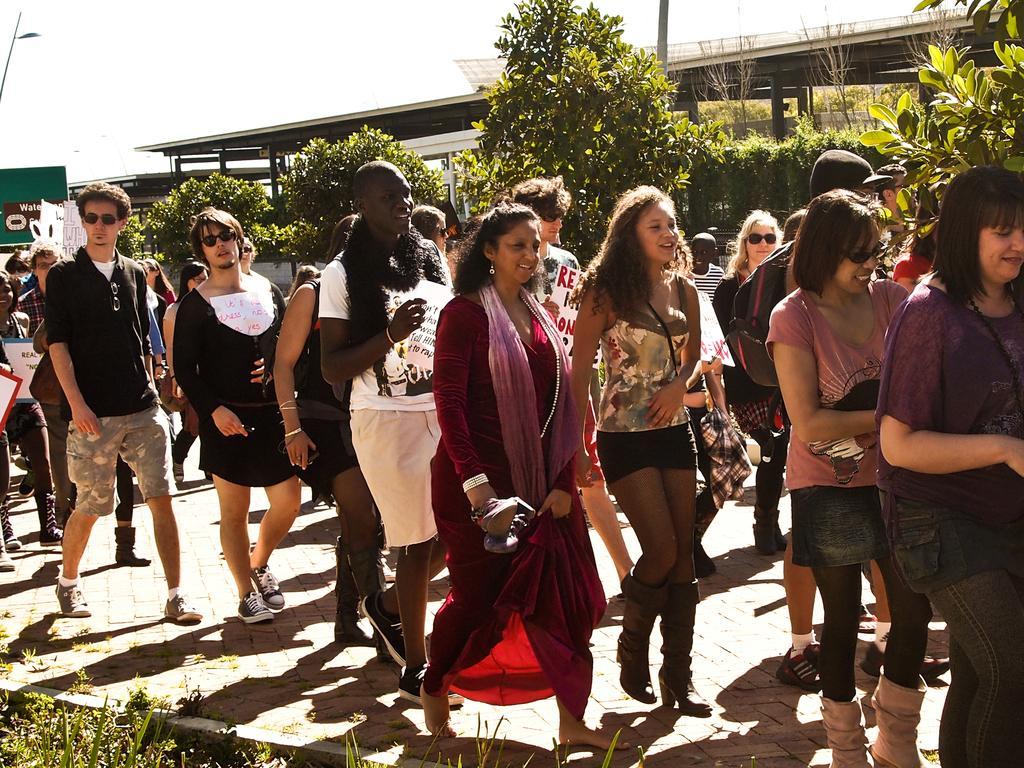How would you summarize this image in a sentence or two? In this image there are a group of people who are walking, at the bottom there is grass and a walkway. And in the background there are some buildings, trees, poles and some boards. 